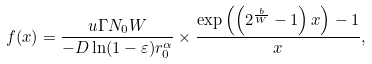Convert formula to latex. <formula><loc_0><loc_0><loc_500><loc_500>f ( x ) = \frac { { u \Gamma { N _ { 0 } } W } } { - D \ln ( 1 - \varepsilon ) r _ { 0 } ^ { \alpha } } \times \frac { \exp \left ( \left ( 2 ^ { \frac { b } { W } } - 1 \right ) x \right ) - 1 } { x } ,</formula> 